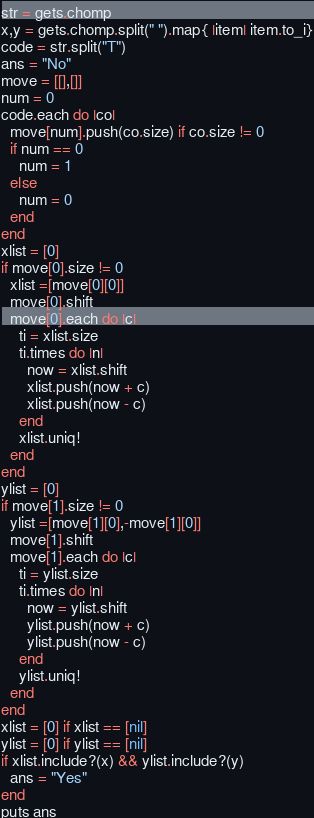<code> <loc_0><loc_0><loc_500><loc_500><_Ruby_>str = gets.chomp
x,y = gets.chomp.split(" ").map{ |item| item.to_i}
code = str.split("T")
ans = "No"
move = [[],[]]
num = 0
code.each do |co|
  move[num].push(co.size) if co.size != 0
  if num == 0
    num = 1
  else
    num = 0
  end
end
xlist = [0]
if move[0].size != 0
  xlist =[move[0][0]]
  move[0].shift
  move[0].each do |c|
    ti = xlist.size
    ti.times do |n|
      now = xlist.shift
      xlist.push(now + c)
      xlist.push(now - c)
    end
    xlist.uniq!
  end
end
ylist = [0]
if move[1].size != 0
  ylist =[move[1][0],-move[1][0]]
  move[1].shift
  move[1].each do |c|
    ti = ylist.size
    ti.times do |n|
      now = ylist.shift
      ylist.push(now + c)
      ylist.push(now - c)
    end
    ylist.uniq!
  end
end
xlist = [0] if xlist == [nil]
ylist = [0] if ylist == [nil]
if xlist.include?(x) && ylist.include?(y)
  ans = "Yes"
end
puts ans</code> 